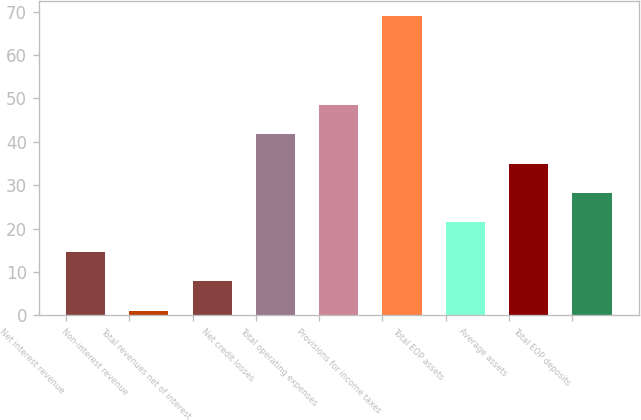Convert chart to OTSL. <chart><loc_0><loc_0><loc_500><loc_500><bar_chart><fcel>Net interest revenue<fcel>Non-interest revenue<fcel>Total revenues net of interest<fcel>Net credit losses<fcel>Total operating expenses<fcel>Provisions for income taxes<fcel>Total EOP assets<fcel>Average assets<fcel>Total EOP deposits<nl><fcel>14.6<fcel>1<fcel>7.8<fcel>41.8<fcel>48.6<fcel>69<fcel>21.4<fcel>35<fcel>28.2<nl></chart> 